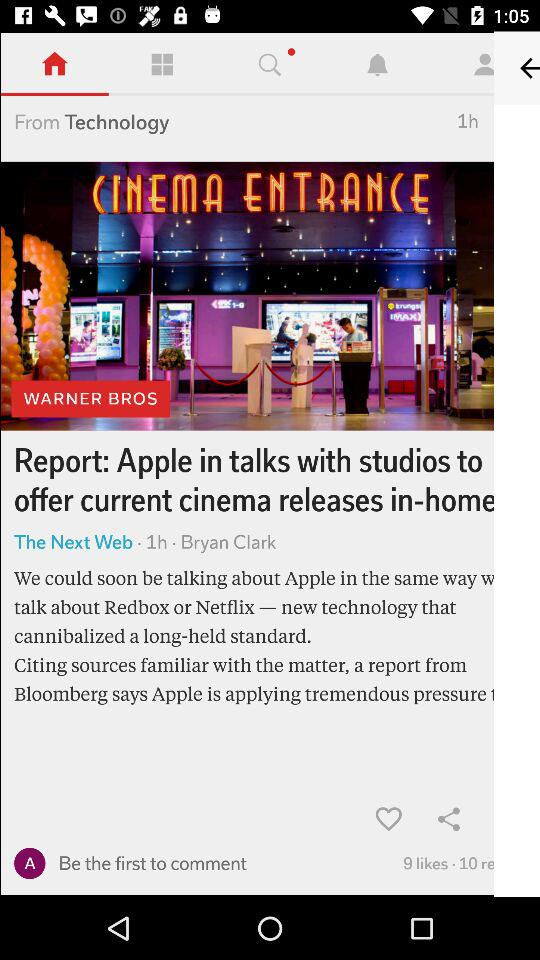How many more people have shared the article than commented on it?
Answer the question using a single word or phrase. 1 